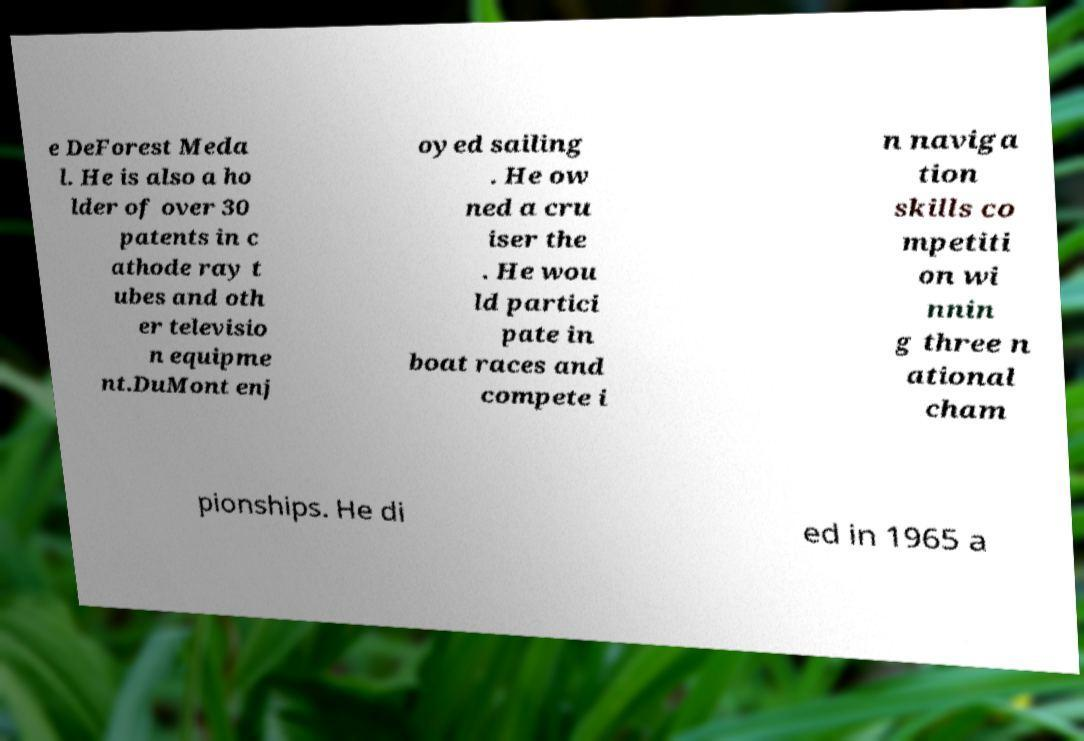For documentation purposes, I need the text within this image transcribed. Could you provide that? e DeForest Meda l. He is also a ho lder of over 30 patents in c athode ray t ubes and oth er televisio n equipme nt.DuMont enj oyed sailing . He ow ned a cru iser the . He wou ld partici pate in boat races and compete i n naviga tion skills co mpetiti on wi nnin g three n ational cham pionships. He di ed in 1965 a 